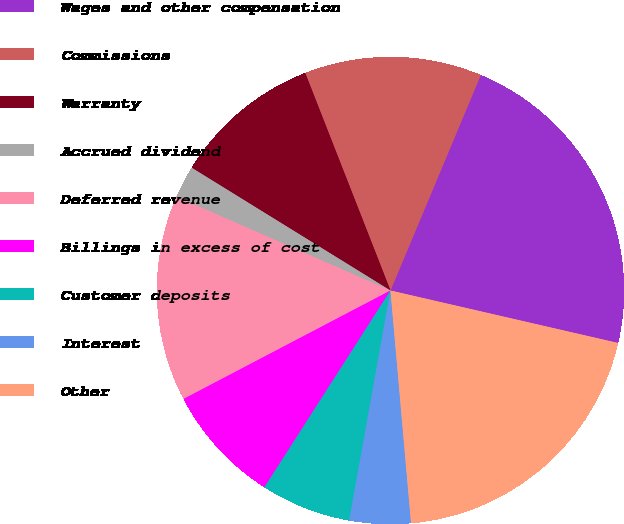<chart> <loc_0><loc_0><loc_500><loc_500><pie_chart><fcel>Wages and other compensation<fcel>Commissions<fcel>Warranty<fcel>Accrued dividend<fcel>Deferred revenue<fcel>Billings in excess of cost<fcel>Customer deposits<fcel>Interest<fcel>Other<nl><fcel>22.29%<fcel>12.26%<fcel>10.25%<fcel>2.23%<fcel>14.26%<fcel>8.25%<fcel>6.24%<fcel>4.23%<fcel>19.99%<nl></chart> 